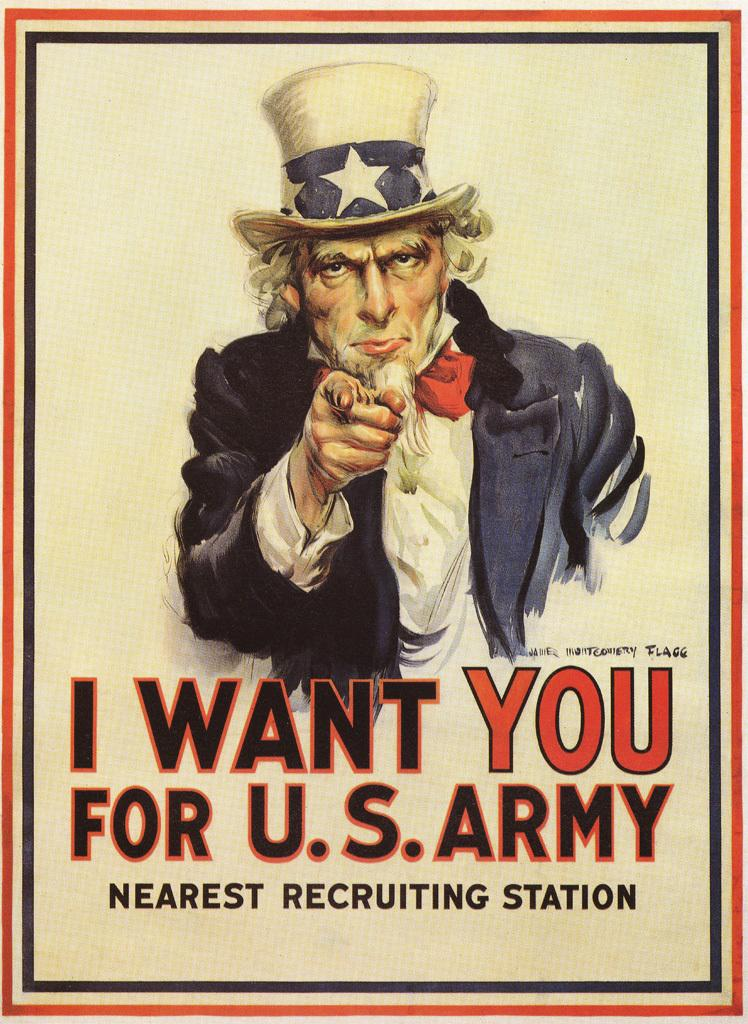What is the main subject of the image? There is a person depicted in the image. Can you describe any additional elements in the image? There is some text at the bottom of the image. What type of hospital is shown in the image? There is no hospital present in the image; it features a person and some text. Can you tell me how many ducks are visible in the image? There are no ducks present in the image. 